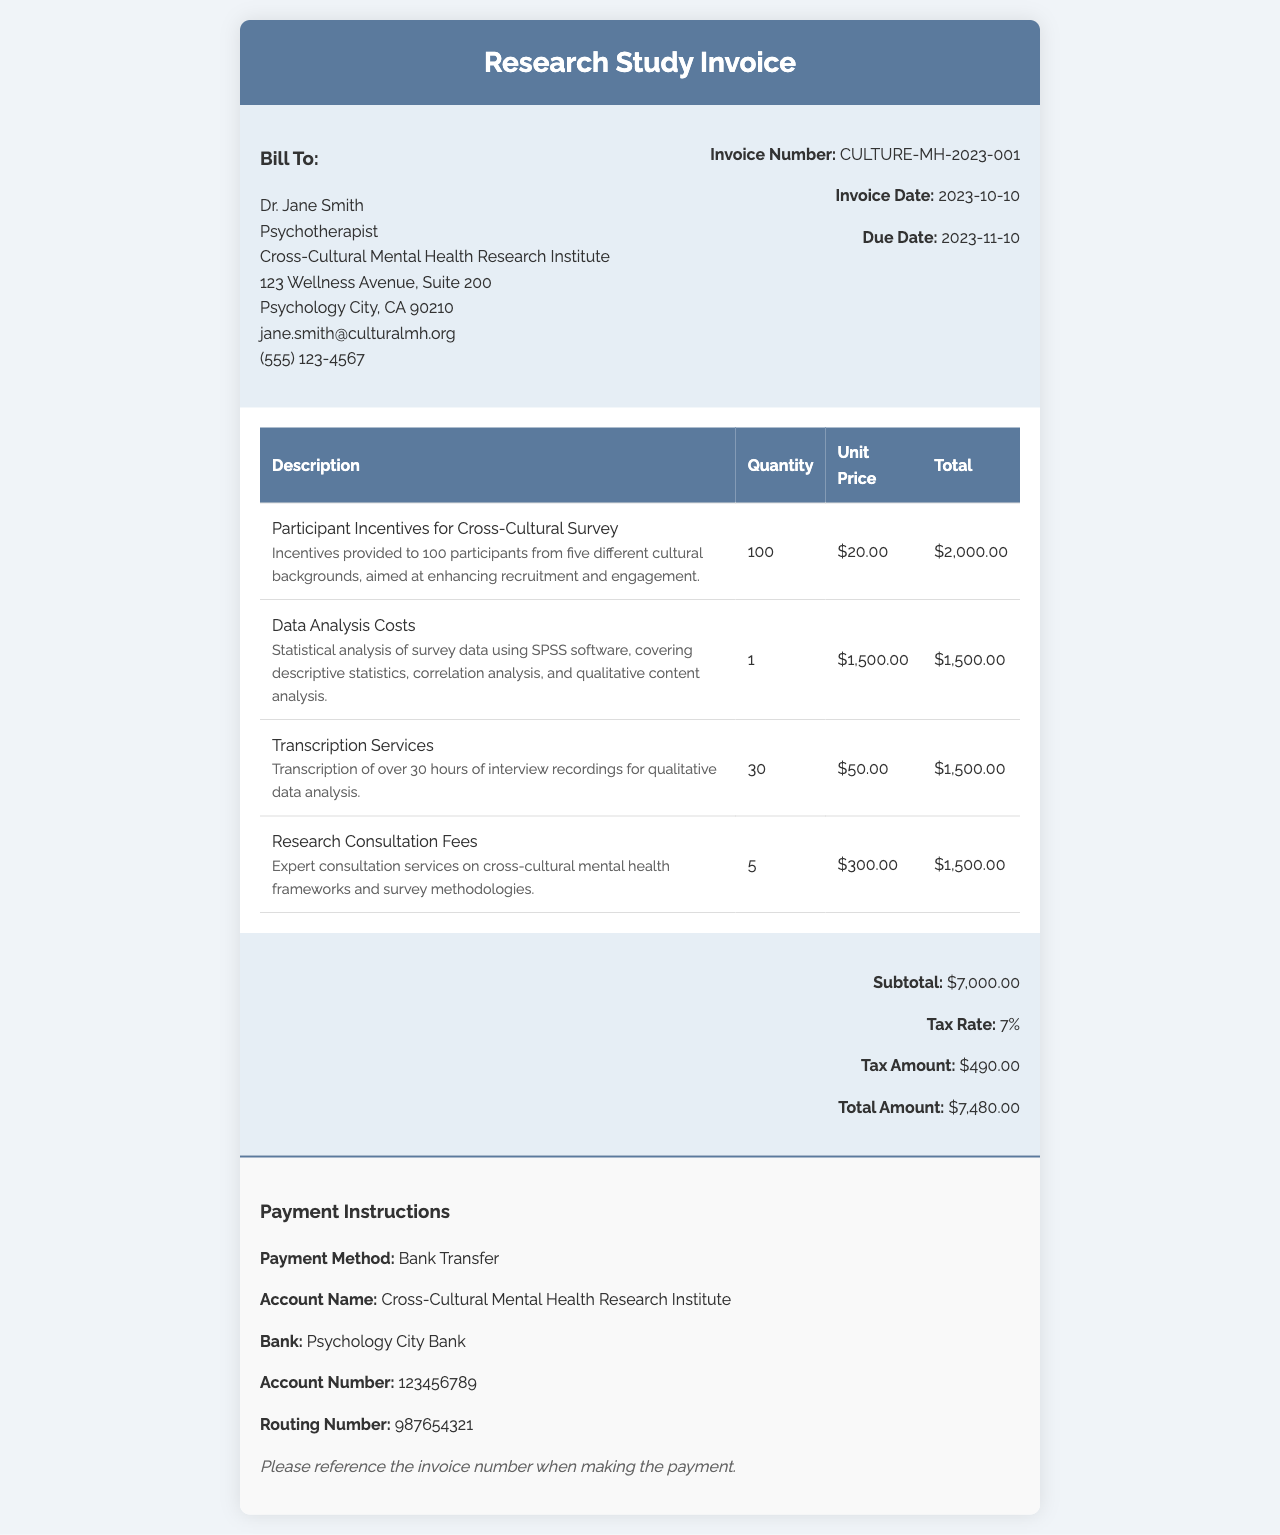What is the invoice number? The invoice number is a unique identifier for this document, listed in the invoice details.
Answer: CULTURE-MH-2023-001 What is the total amount due? The total amount is calculated by adding the subtotal and tax amount provided at the end of the invoice.
Answer: $7,480.00 How many participants received incentives? The document states the quantity of participants that received incentives for the survey.
Answer: 100 What are the transcription services costs? The transcription services have a specific cost listed under the items section of the invoice.
Answer: $1,500.00 What is the tax rate applied? The tax rate is a percentage that has been applied to the subtotal, mentioned in the summary section.
Answer: 7% What was the primary method of payment requested? The payment instructions detail the method requested for settling the invoice.
Answer: Bank Transfer What is the due date for this invoice? The due date indicates when payment for the invoice is expected, featured prominently in the invoice details.
Answer: 2023-11-10 What type of analysis was conducted for the research study? The itemized description mentions the type of analysis that was performed on the survey data.
Answer: Statistical analysis What is included in the participant incentives description? The invoice provides details on what the participant incentives were intended to address for the survey.
Answer: Enhancing recruitment and engagement 